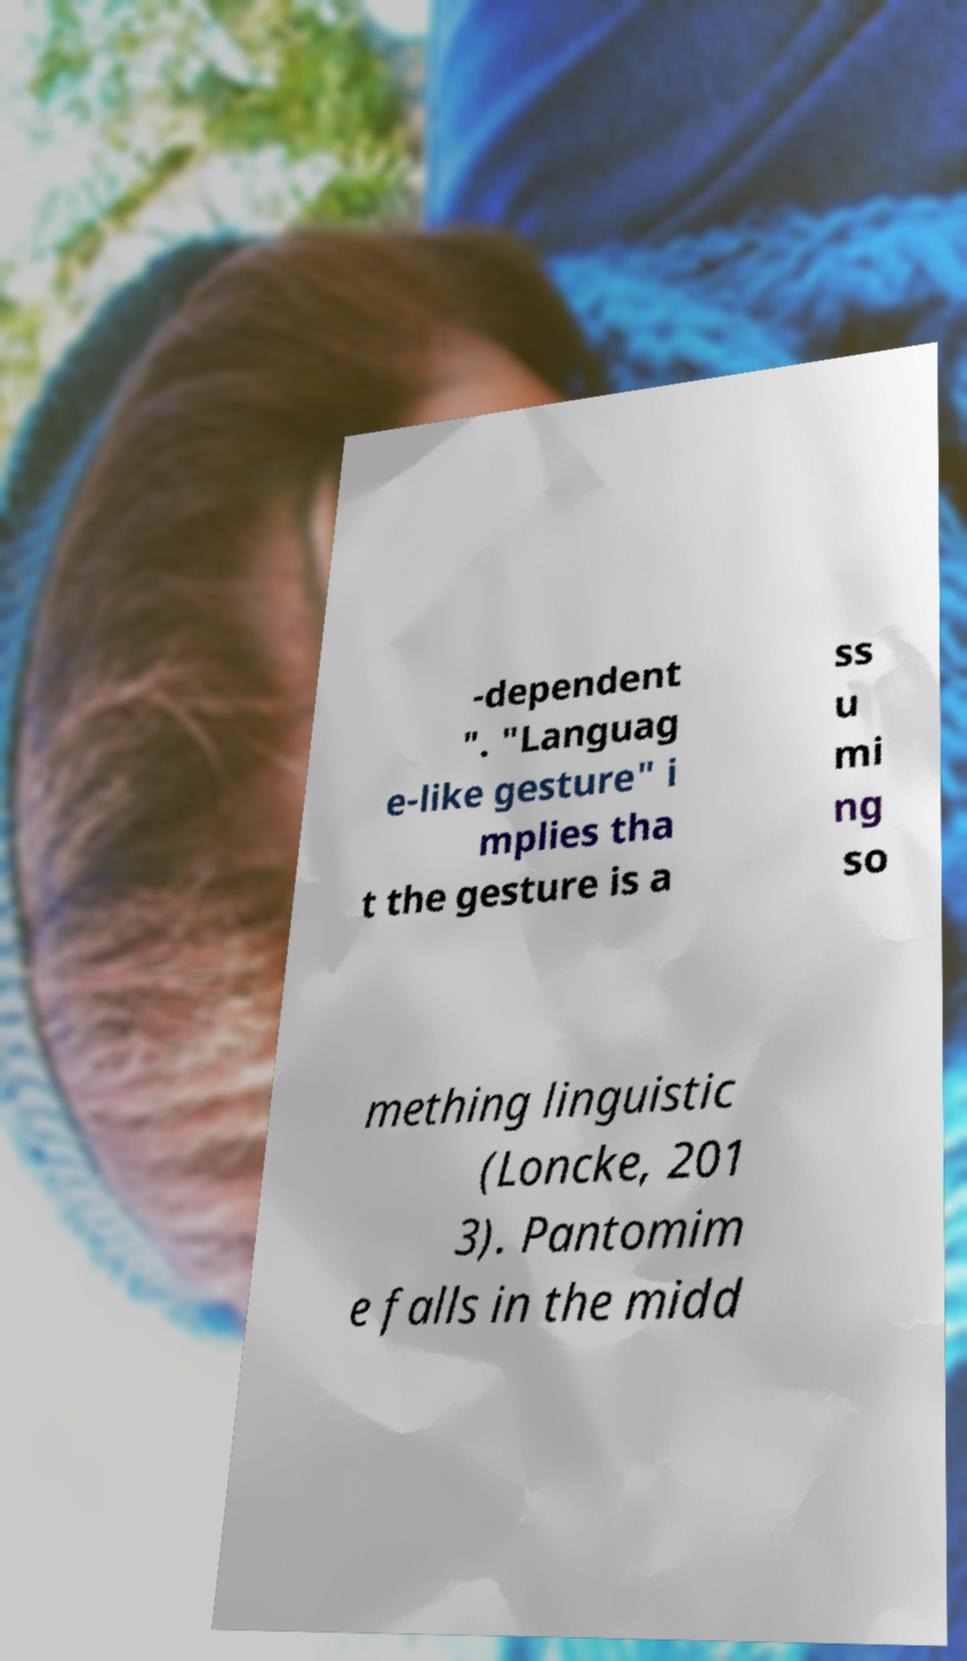Please read and relay the text visible in this image. What does it say? -dependent ". "Languag e-like gesture" i mplies tha t the gesture is a ss u mi ng so mething linguistic (Loncke, 201 3). Pantomim e falls in the midd 